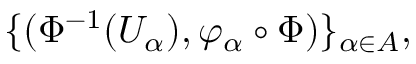Convert formula to latex. <formula><loc_0><loc_0><loc_500><loc_500>\{ ( \Phi ^ { - 1 } ( U _ { \alpha } ) , \varphi _ { \alpha } \circ \Phi ) \} _ { \alpha \in A } ,</formula> 